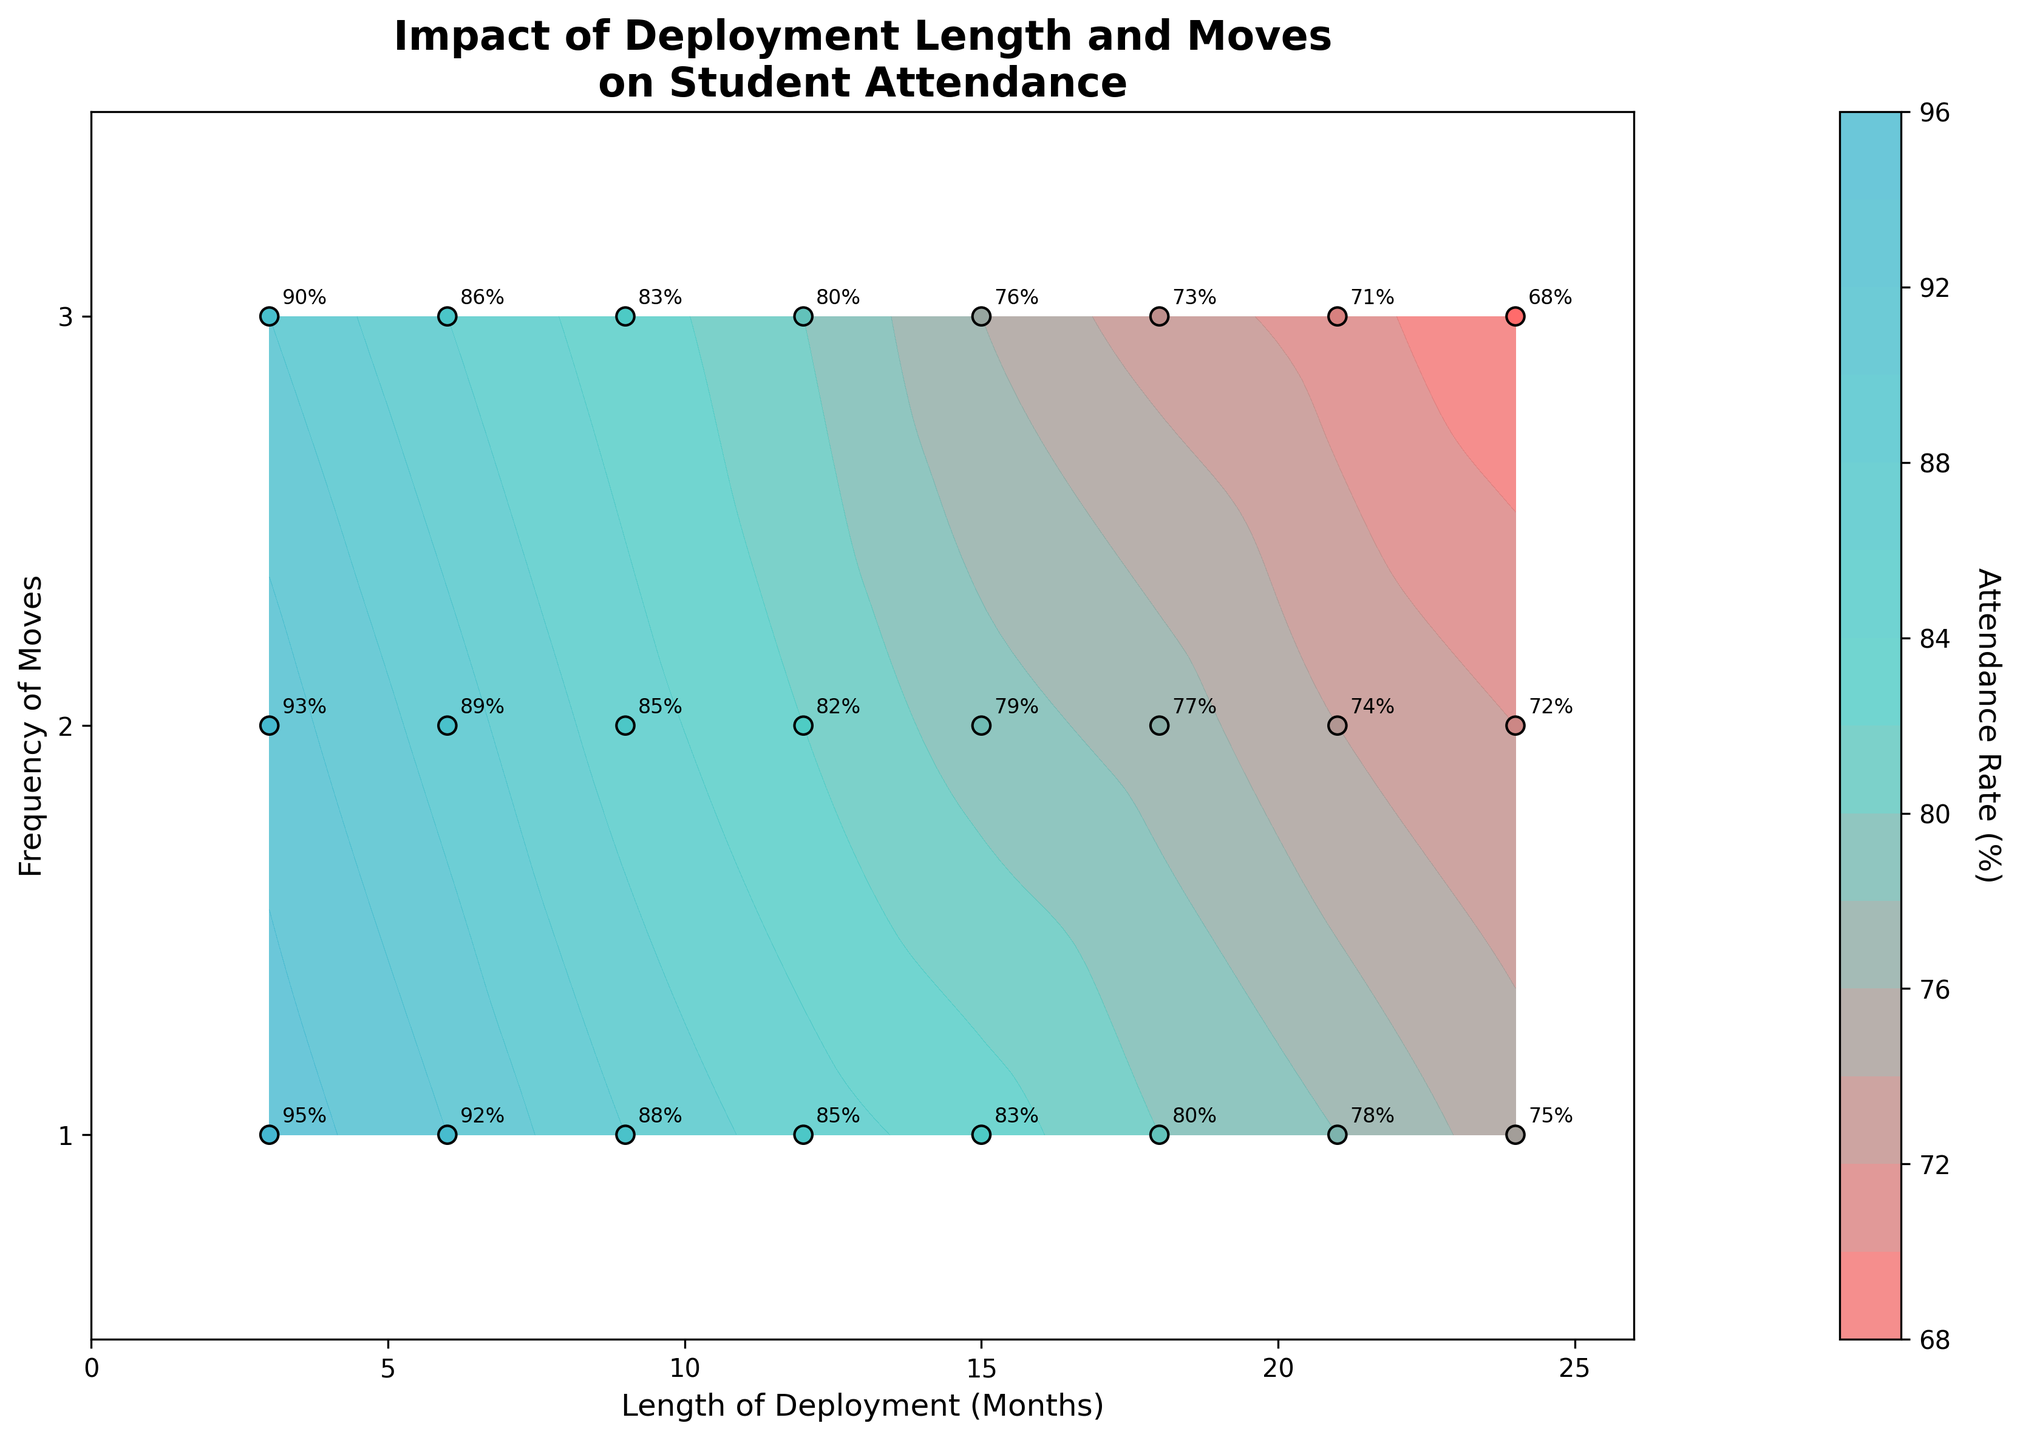Which axis represents the length of parental deployment? The x-axis represents the length of deployment in months, as indicated by the label "Length of Deployment (Months)".
Answer: The x-axis What are the values shown on the color bar? The color bar shows the attendance rates in percentage, ranging from approximately 68% to 95%.
Answer: Approximately 68% to 95% What is the attendance rate when the length of deployment is 6 months and the frequency of moves is 1? The contour plot shows specific points, and for 6 months of deployment with 1 move, an attendance rate of 92% is annotated.
Answer: 92% How does attendance rate change as the length of deployment increases from 3 months to 24 months? Overall, the attendance rates decrease as the length of deployment increases from 3 months (with a high of 95%) to 24 months (with a low of 68%).
Answer: Decreases What can you infer about the relationship between the frequency of moves and student attendance rate? As the frequency of moves increases, the attendance rate tends to decrease for nearly all lengths of deployment.
Answer: Decreases Which combination of length of deployment and frequency of moves results in the lowest attendance rate? The lowest attendance rate appears at 24 months of deployment with a frequency of 3 moves, showing an attendance rate of 68%.
Answer: 24 months, 3 moves At which length of deployment and frequency of moves is the attendance rate 85%? The attendance rate is 85% at a length of deployment of 9 months with 2 moves, which matches the annotation on the plot.
Answer: 9 months, 2 moves Compare the attendance rate for a student with a deployment length of 18 months with 1 move to a student with a deployment length of 18 months with 3 moves. A student with 18 months deployment and 1 move has an attendance rate of 80%, while a student with the same deployment length but 3 moves has a rate of 73%.
Answer: 80% vs 73% What is the general trend observed for attendance rate as both deployment length and frequency of moves increase? The attendance rate generally decreases as both deployment length and frequency of moves increase, as indicated by the contour plot and lower percentage annotations in the upper right corner.
Answer: Decreases 